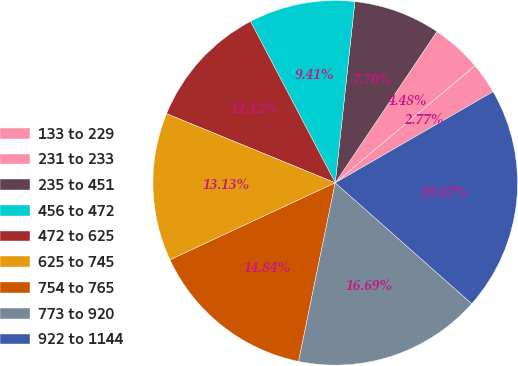Convert chart to OTSL. <chart><loc_0><loc_0><loc_500><loc_500><pie_chart><fcel>133 to 229<fcel>231 to 233<fcel>235 to 451<fcel>456 to 472<fcel>472 to 625<fcel>625 to 745<fcel>754 to 765<fcel>773 to 920<fcel>922 to 1144<nl><fcel>2.77%<fcel>4.48%<fcel>7.7%<fcel>9.41%<fcel>11.12%<fcel>13.13%<fcel>14.84%<fcel>16.69%<fcel>19.87%<nl></chart> 